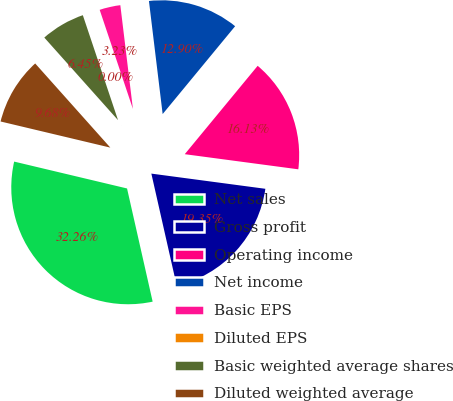Convert chart to OTSL. <chart><loc_0><loc_0><loc_500><loc_500><pie_chart><fcel>Net sales<fcel>Gross profit<fcel>Operating income<fcel>Net income<fcel>Basic EPS<fcel>Diluted EPS<fcel>Basic weighted average shares<fcel>Diluted weighted average<nl><fcel>32.26%<fcel>19.35%<fcel>16.13%<fcel>12.9%<fcel>3.23%<fcel>0.0%<fcel>6.45%<fcel>9.68%<nl></chart> 